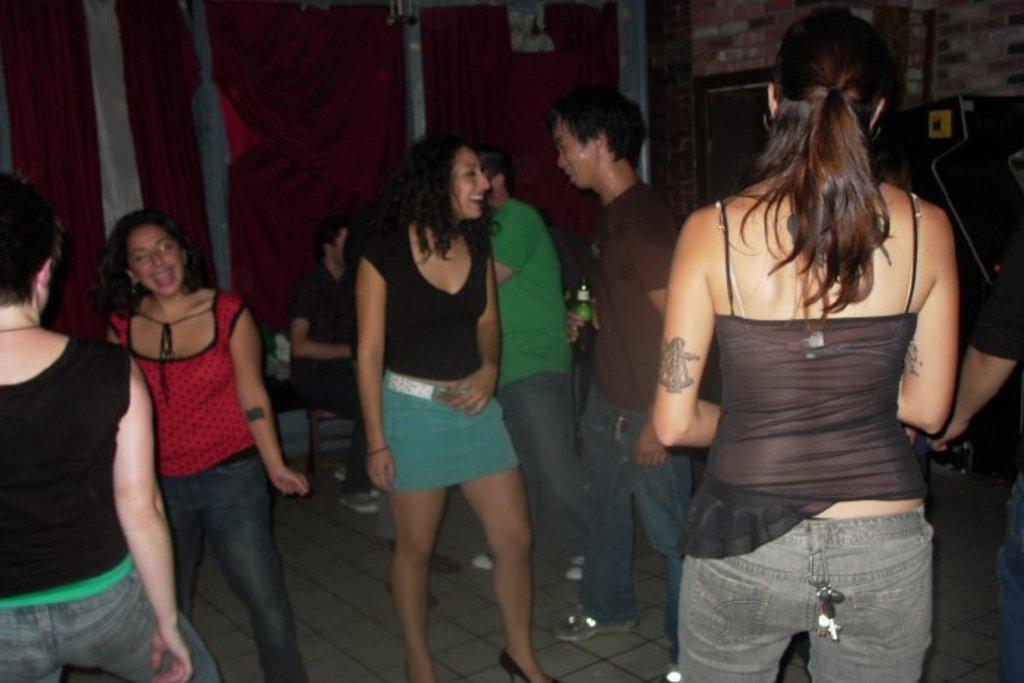Can you describe this image briefly? In this image, we can see people and one of them is sitting on the chair and we can see a person holding a bottle. In the background, there are curtains and we can see a board on the wall. At the bottom, there is a floor. 